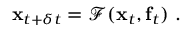Convert formula to latex. <formula><loc_0><loc_0><loc_500><loc_500>x _ { t + \delta t } = \mathcal { F } ( x _ { t } , f _ { t } ) .</formula> 